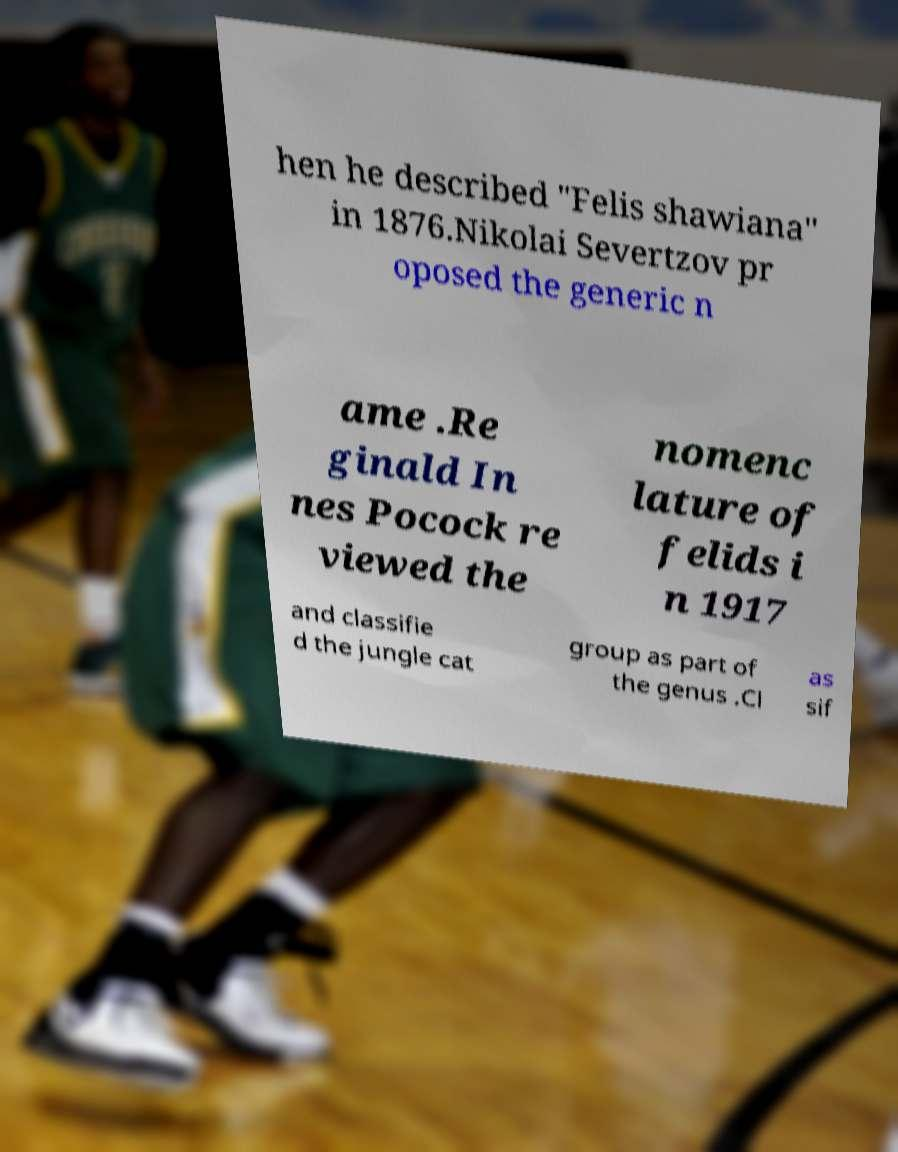Can you read and provide the text displayed in the image?This photo seems to have some interesting text. Can you extract and type it out for me? hen he described "Felis shawiana" in 1876.Nikolai Severtzov pr oposed the generic n ame .Re ginald In nes Pocock re viewed the nomenc lature of felids i n 1917 and classifie d the jungle cat group as part of the genus .Cl as sif 